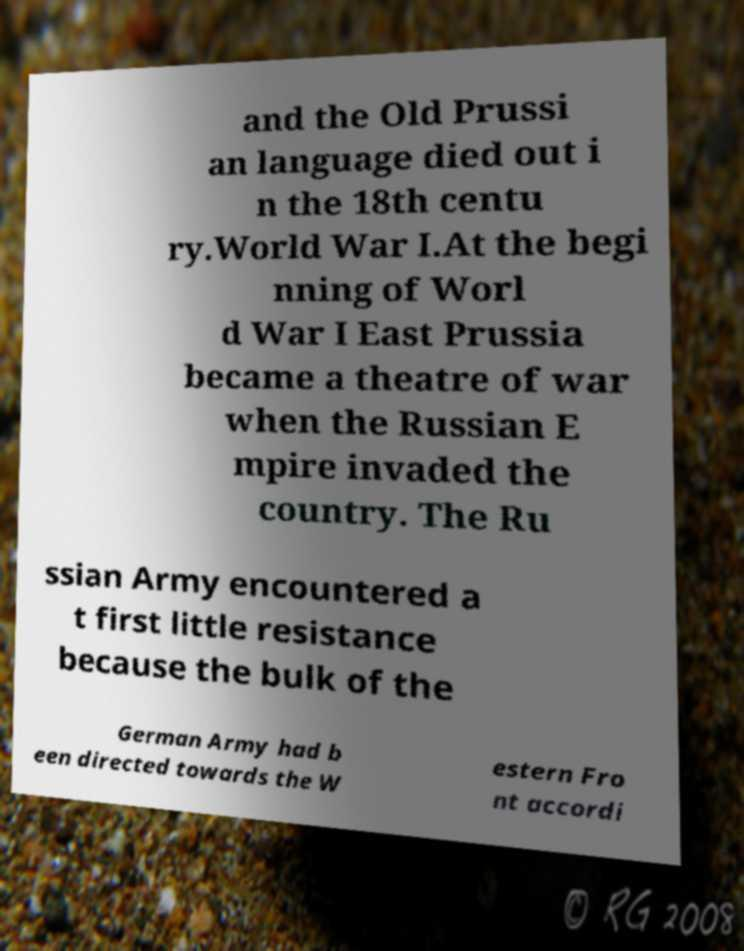I need the written content from this picture converted into text. Can you do that? and the Old Prussi an language died out i n the 18th centu ry.World War I.At the begi nning of Worl d War I East Prussia became a theatre of war when the Russian E mpire invaded the country. The Ru ssian Army encountered a t first little resistance because the bulk of the German Army had b een directed towards the W estern Fro nt accordi 